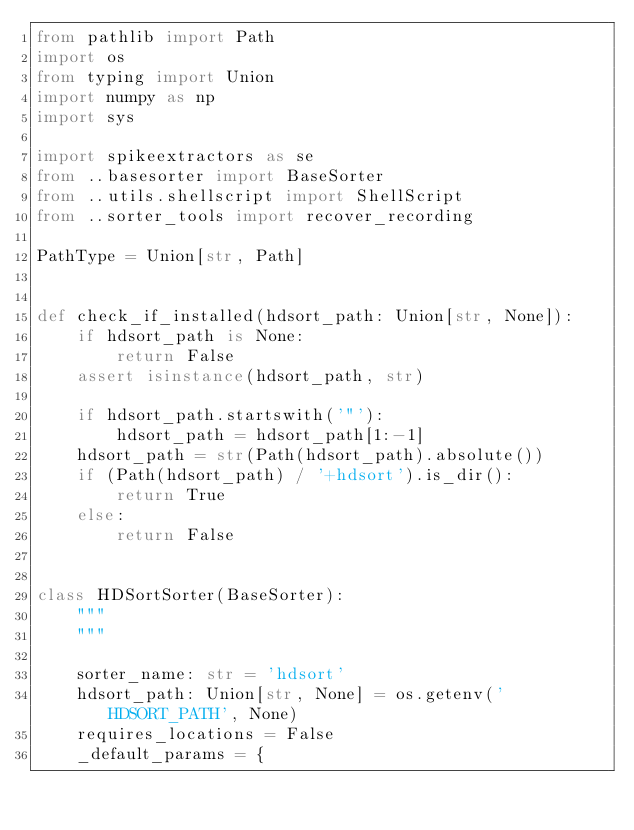Convert code to text. <code><loc_0><loc_0><loc_500><loc_500><_Python_>from pathlib import Path
import os
from typing import Union
import numpy as np
import sys

import spikeextractors as se
from ..basesorter import BaseSorter
from ..utils.shellscript import ShellScript
from ..sorter_tools import recover_recording

PathType = Union[str, Path]


def check_if_installed(hdsort_path: Union[str, None]):
    if hdsort_path is None:
        return False
    assert isinstance(hdsort_path, str)

    if hdsort_path.startswith('"'):
        hdsort_path = hdsort_path[1:-1]
    hdsort_path = str(Path(hdsort_path).absolute())
    if (Path(hdsort_path) / '+hdsort').is_dir():
        return True
    else:
        return False


class HDSortSorter(BaseSorter):
    """
    """

    sorter_name: str = 'hdsort'
    hdsort_path: Union[str, None] = os.getenv('HDSORT_PATH', None)
    requires_locations = False
    _default_params = {</code> 